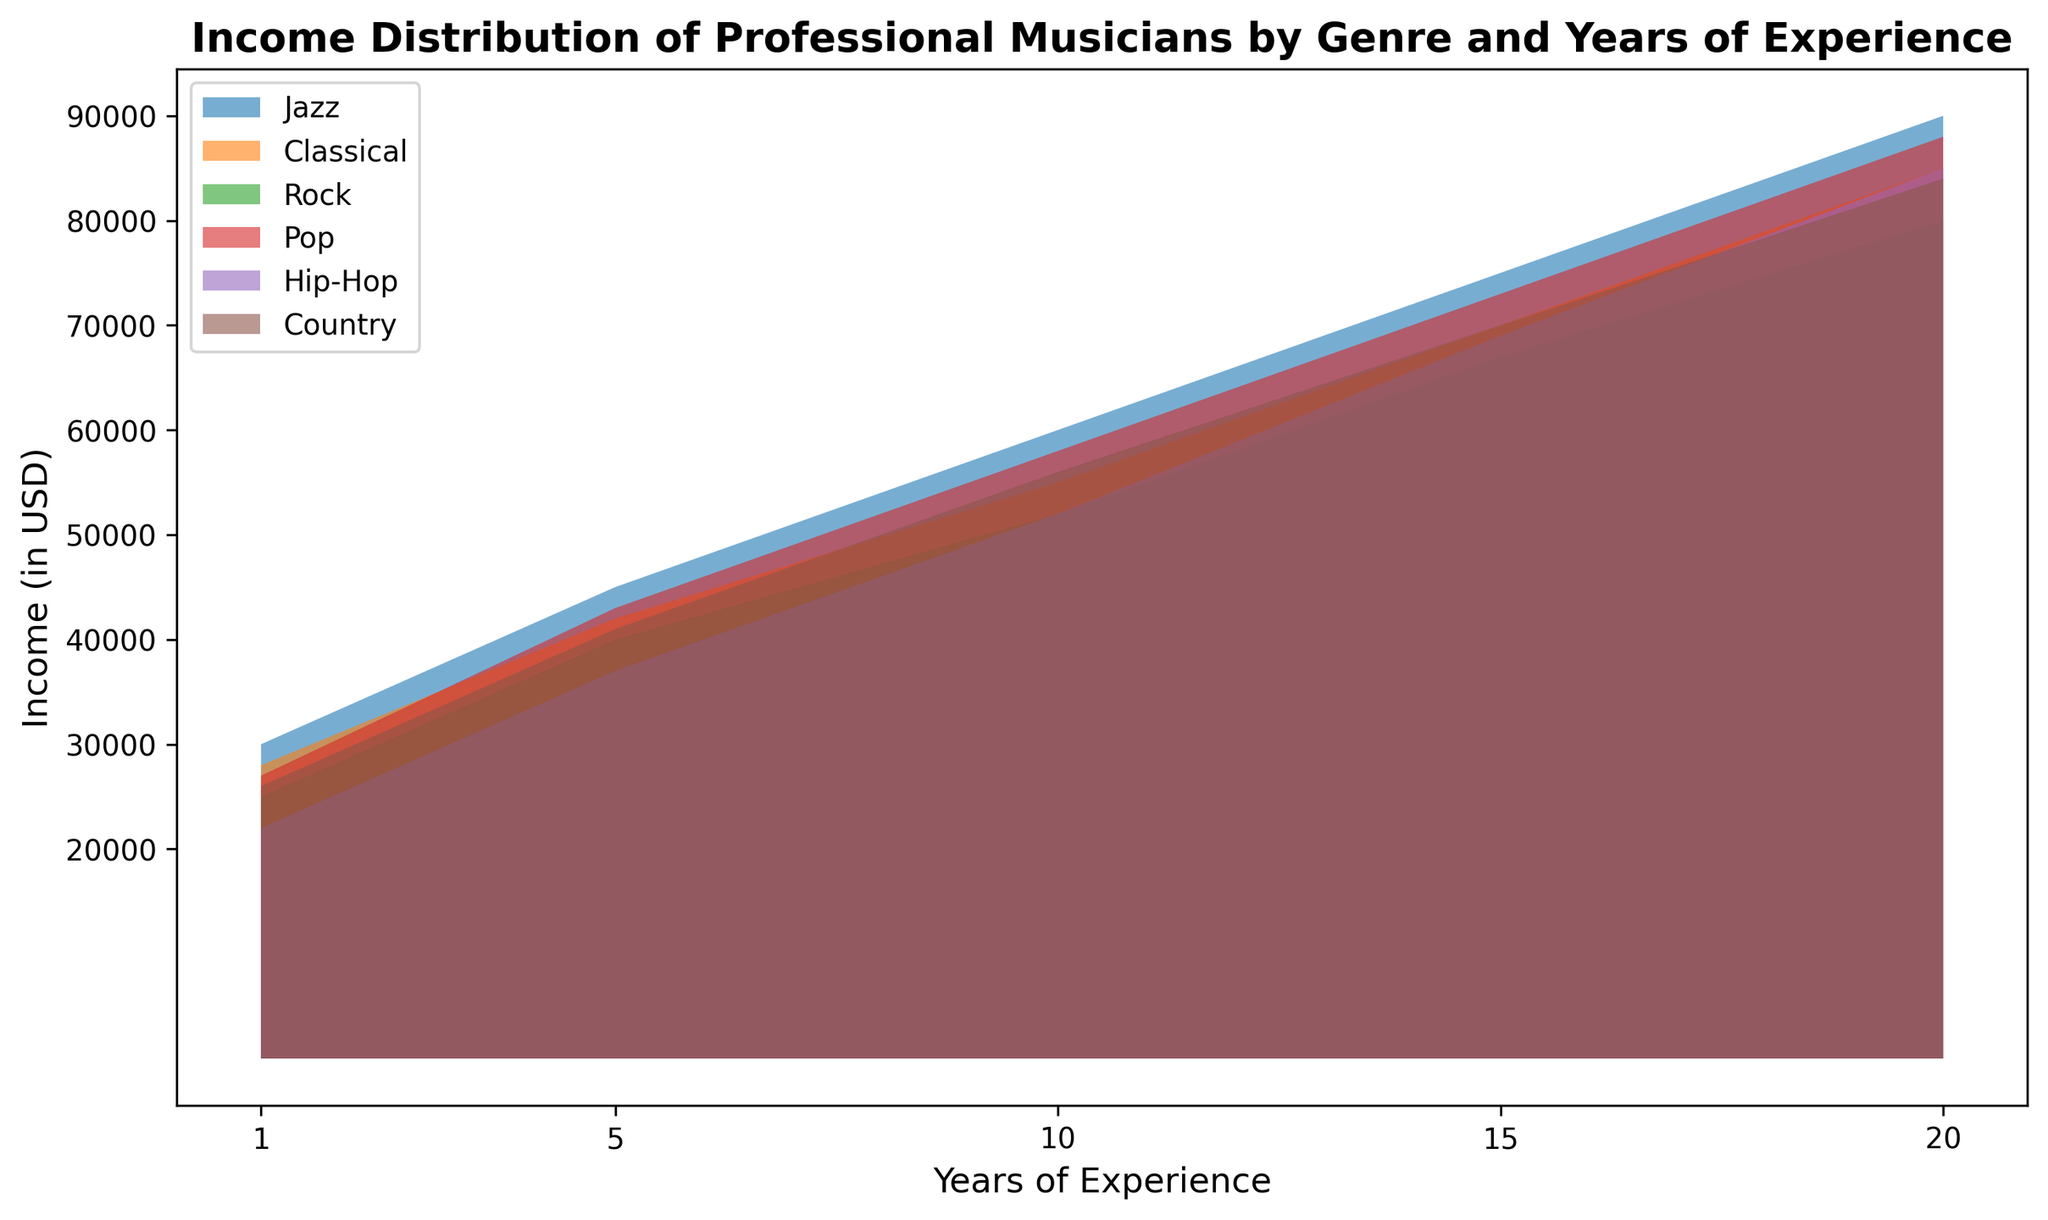What is the highest income value across all genres and years of experience? To find the highest income, look for the peak value on any of the area charts. The peak value is present at the end of each genre line. The highest value among all should be identified.
Answer: 90000 Which genre shows the highest income after 10 years of experience? Check the income values for each genre specifically at the 10-year mark. Compare the income values shown for Jazz, Classical, Rock, Pop, Hip-Hop, and Country. Jazz has the highest value.
Answer: Jazz Does the income of Hip-Hop musicians after 1 year of experience exceed that of Pop musicians with the same experience? Compare the income values for both Hip-Hop and Pop genres at the 1-year mark by looking at the start of their respective charts. Hip-Hop income is 22000, while Pop income is 27000.
Answer: No What is the difference in income between Classical musicians and Rock musicians after 15 years of experience? Look at the income values for Classical and Rock genres at the 15-year mark. Classical shows 70000 and Rock shows 67000. Subtract the Rock income from the Classical income.
Answer: 3000 Between how many years of experience do Pop musicians see their income increase from 27000 to 73000? Identify the points on the Pop genre chart where the income values are 27000 and 73000. 27000 is at 1 year, and 73000 is at 15 years, so subtract the starting year from the ending year.
Answer: 14 years What is the average income of Jazz musicians over all years of experience shown? Sum the income values for Jazz musicians across all years of experience (30000 + 45000 + 60000 + 75000 + 90000). Then, divide by the number of data points, which is 5.
Answer: 60000 Which genre shows the smallest income increment from 5 to 10 years of experience? Calculate the income increment from 5 to 10 years for each genre by subtracting the income at 5 years from the income at 10 years. Compare the increment values and find the smallest one.
Answer: Rock What is the total income of Country musicians with 1, 10, and 20 years of experience combined? Add the income values for Country musicians with 1 year, 10 years, and 20 years of experience (26000 + 56000 + 84000).
Answer: 166000 